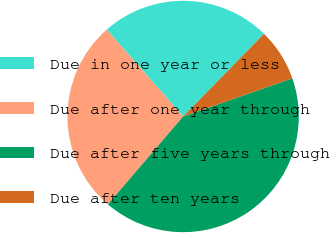<chart> <loc_0><loc_0><loc_500><loc_500><pie_chart><fcel>Due in one year or less<fcel>Due after one year through<fcel>Due after five years through<fcel>Due after ten years<nl><fcel>23.82%<fcel>27.24%<fcel>41.61%<fcel>7.33%<nl></chart> 